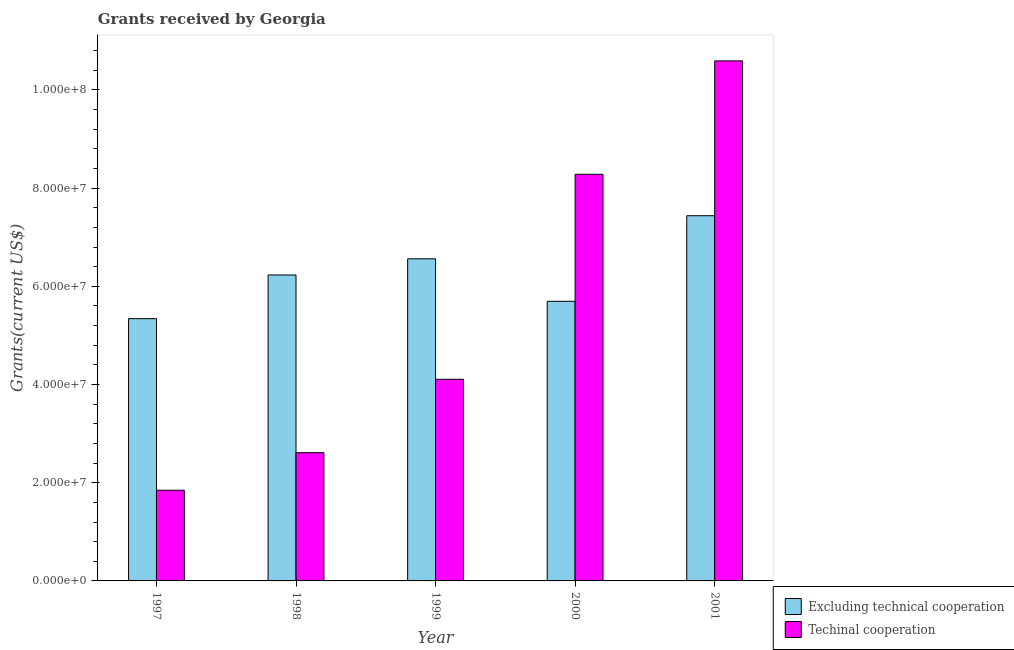How many different coloured bars are there?
Your answer should be very brief. 2. How many groups of bars are there?
Ensure brevity in your answer.  5. How many bars are there on the 3rd tick from the left?
Provide a succinct answer. 2. How many bars are there on the 5th tick from the right?
Keep it short and to the point. 2. In how many cases, is the number of bars for a given year not equal to the number of legend labels?
Offer a terse response. 0. What is the amount of grants received(excluding technical cooperation) in 1998?
Give a very brief answer. 6.23e+07. Across all years, what is the maximum amount of grants received(including technical cooperation)?
Ensure brevity in your answer.  1.06e+08. Across all years, what is the minimum amount of grants received(excluding technical cooperation)?
Your answer should be very brief. 5.34e+07. What is the total amount of grants received(excluding technical cooperation) in the graph?
Ensure brevity in your answer.  3.13e+08. What is the difference between the amount of grants received(including technical cooperation) in 1997 and that in 2000?
Keep it short and to the point. -6.44e+07. What is the difference between the amount of grants received(excluding technical cooperation) in 1997 and the amount of grants received(including technical cooperation) in 1998?
Give a very brief answer. -8.89e+06. What is the average amount of grants received(excluding technical cooperation) per year?
Offer a terse response. 6.25e+07. In how many years, is the amount of grants received(excluding technical cooperation) greater than 52000000 US$?
Provide a short and direct response. 5. What is the ratio of the amount of grants received(including technical cooperation) in 1998 to that in 2000?
Keep it short and to the point. 0.32. Is the amount of grants received(including technical cooperation) in 1997 less than that in 2001?
Keep it short and to the point. Yes. What is the difference between the highest and the second highest amount of grants received(excluding technical cooperation)?
Give a very brief answer. 8.77e+06. What is the difference between the highest and the lowest amount of grants received(including technical cooperation)?
Your answer should be very brief. 8.74e+07. Is the sum of the amount of grants received(including technical cooperation) in 1999 and 2000 greater than the maximum amount of grants received(excluding technical cooperation) across all years?
Offer a terse response. Yes. What does the 1st bar from the left in 2000 represents?
Offer a very short reply. Excluding technical cooperation. What does the 2nd bar from the right in 1998 represents?
Your answer should be very brief. Excluding technical cooperation. How many bars are there?
Offer a very short reply. 10. Are all the bars in the graph horizontal?
Your response must be concise. No. How many years are there in the graph?
Your answer should be compact. 5. Are the values on the major ticks of Y-axis written in scientific E-notation?
Make the answer very short. Yes. What is the title of the graph?
Your answer should be compact. Grants received by Georgia. What is the label or title of the Y-axis?
Your response must be concise. Grants(current US$). What is the Grants(current US$) of Excluding technical cooperation in 1997?
Provide a short and direct response. 5.34e+07. What is the Grants(current US$) of Techinal cooperation in 1997?
Provide a short and direct response. 1.85e+07. What is the Grants(current US$) of Excluding technical cooperation in 1998?
Make the answer very short. 6.23e+07. What is the Grants(current US$) in Techinal cooperation in 1998?
Your answer should be very brief. 2.61e+07. What is the Grants(current US$) in Excluding technical cooperation in 1999?
Provide a short and direct response. 6.56e+07. What is the Grants(current US$) in Techinal cooperation in 1999?
Offer a terse response. 4.11e+07. What is the Grants(current US$) in Excluding technical cooperation in 2000?
Offer a terse response. 5.70e+07. What is the Grants(current US$) of Techinal cooperation in 2000?
Your answer should be compact. 8.28e+07. What is the Grants(current US$) in Excluding technical cooperation in 2001?
Ensure brevity in your answer.  7.44e+07. What is the Grants(current US$) of Techinal cooperation in 2001?
Your response must be concise. 1.06e+08. Across all years, what is the maximum Grants(current US$) of Excluding technical cooperation?
Your response must be concise. 7.44e+07. Across all years, what is the maximum Grants(current US$) in Techinal cooperation?
Give a very brief answer. 1.06e+08. Across all years, what is the minimum Grants(current US$) of Excluding technical cooperation?
Offer a very short reply. 5.34e+07. Across all years, what is the minimum Grants(current US$) in Techinal cooperation?
Offer a very short reply. 1.85e+07. What is the total Grants(current US$) in Excluding technical cooperation in the graph?
Ensure brevity in your answer.  3.13e+08. What is the total Grants(current US$) of Techinal cooperation in the graph?
Your response must be concise. 2.74e+08. What is the difference between the Grants(current US$) of Excluding technical cooperation in 1997 and that in 1998?
Offer a very short reply. -8.89e+06. What is the difference between the Grants(current US$) in Techinal cooperation in 1997 and that in 1998?
Offer a very short reply. -7.65e+06. What is the difference between the Grants(current US$) in Excluding technical cooperation in 1997 and that in 1999?
Keep it short and to the point. -1.22e+07. What is the difference between the Grants(current US$) of Techinal cooperation in 1997 and that in 1999?
Ensure brevity in your answer.  -2.26e+07. What is the difference between the Grants(current US$) in Excluding technical cooperation in 1997 and that in 2000?
Give a very brief answer. -3.53e+06. What is the difference between the Grants(current US$) of Techinal cooperation in 1997 and that in 2000?
Make the answer very short. -6.44e+07. What is the difference between the Grants(current US$) of Excluding technical cooperation in 1997 and that in 2001?
Provide a short and direct response. -2.10e+07. What is the difference between the Grants(current US$) in Techinal cooperation in 1997 and that in 2001?
Give a very brief answer. -8.74e+07. What is the difference between the Grants(current US$) in Excluding technical cooperation in 1998 and that in 1999?
Give a very brief answer. -3.30e+06. What is the difference between the Grants(current US$) in Techinal cooperation in 1998 and that in 1999?
Offer a very short reply. -1.50e+07. What is the difference between the Grants(current US$) of Excluding technical cooperation in 1998 and that in 2000?
Ensure brevity in your answer.  5.36e+06. What is the difference between the Grants(current US$) of Techinal cooperation in 1998 and that in 2000?
Ensure brevity in your answer.  -5.67e+07. What is the difference between the Grants(current US$) of Excluding technical cooperation in 1998 and that in 2001?
Provide a succinct answer. -1.21e+07. What is the difference between the Grants(current US$) in Techinal cooperation in 1998 and that in 2001?
Give a very brief answer. -7.98e+07. What is the difference between the Grants(current US$) in Excluding technical cooperation in 1999 and that in 2000?
Your response must be concise. 8.66e+06. What is the difference between the Grants(current US$) of Techinal cooperation in 1999 and that in 2000?
Provide a short and direct response. -4.18e+07. What is the difference between the Grants(current US$) of Excluding technical cooperation in 1999 and that in 2001?
Your response must be concise. -8.77e+06. What is the difference between the Grants(current US$) of Techinal cooperation in 1999 and that in 2001?
Your answer should be compact. -6.48e+07. What is the difference between the Grants(current US$) of Excluding technical cooperation in 2000 and that in 2001?
Provide a short and direct response. -1.74e+07. What is the difference between the Grants(current US$) of Techinal cooperation in 2000 and that in 2001?
Provide a short and direct response. -2.31e+07. What is the difference between the Grants(current US$) of Excluding technical cooperation in 1997 and the Grants(current US$) of Techinal cooperation in 1998?
Make the answer very short. 2.73e+07. What is the difference between the Grants(current US$) of Excluding technical cooperation in 1997 and the Grants(current US$) of Techinal cooperation in 1999?
Provide a short and direct response. 1.24e+07. What is the difference between the Grants(current US$) of Excluding technical cooperation in 1997 and the Grants(current US$) of Techinal cooperation in 2000?
Your response must be concise. -2.94e+07. What is the difference between the Grants(current US$) in Excluding technical cooperation in 1997 and the Grants(current US$) in Techinal cooperation in 2001?
Your answer should be very brief. -5.25e+07. What is the difference between the Grants(current US$) in Excluding technical cooperation in 1998 and the Grants(current US$) in Techinal cooperation in 1999?
Make the answer very short. 2.12e+07. What is the difference between the Grants(current US$) in Excluding technical cooperation in 1998 and the Grants(current US$) in Techinal cooperation in 2000?
Provide a short and direct response. -2.05e+07. What is the difference between the Grants(current US$) in Excluding technical cooperation in 1998 and the Grants(current US$) in Techinal cooperation in 2001?
Provide a succinct answer. -4.36e+07. What is the difference between the Grants(current US$) in Excluding technical cooperation in 1999 and the Grants(current US$) in Techinal cooperation in 2000?
Provide a short and direct response. -1.72e+07. What is the difference between the Grants(current US$) of Excluding technical cooperation in 1999 and the Grants(current US$) of Techinal cooperation in 2001?
Your response must be concise. -4.03e+07. What is the difference between the Grants(current US$) in Excluding technical cooperation in 2000 and the Grants(current US$) in Techinal cooperation in 2001?
Your answer should be compact. -4.90e+07. What is the average Grants(current US$) of Excluding technical cooperation per year?
Provide a short and direct response. 6.25e+07. What is the average Grants(current US$) in Techinal cooperation per year?
Make the answer very short. 5.49e+07. In the year 1997, what is the difference between the Grants(current US$) of Excluding technical cooperation and Grants(current US$) of Techinal cooperation?
Make the answer very short. 3.50e+07. In the year 1998, what is the difference between the Grants(current US$) in Excluding technical cooperation and Grants(current US$) in Techinal cooperation?
Give a very brief answer. 3.62e+07. In the year 1999, what is the difference between the Grants(current US$) in Excluding technical cooperation and Grants(current US$) in Techinal cooperation?
Make the answer very short. 2.45e+07. In the year 2000, what is the difference between the Grants(current US$) of Excluding technical cooperation and Grants(current US$) of Techinal cooperation?
Provide a short and direct response. -2.59e+07. In the year 2001, what is the difference between the Grants(current US$) in Excluding technical cooperation and Grants(current US$) in Techinal cooperation?
Offer a very short reply. -3.15e+07. What is the ratio of the Grants(current US$) of Excluding technical cooperation in 1997 to that in 1998?
Offer a very short reply. 0.86. What is the ratio of the Grants(current US$) of Techinal cooperation in 1997 to that in 1998?
Provide a short and direct response. 0.71. What is the ratio of the Grants(current US$) in Excluding technical cooperation in 1997 to that in 1999?
Keep it short and to the point. 0.81. What is the ratio of the Grants(current US$) of Techinal cooperation in 1997 to that in 1999?
Ensure brevity in your answer.  0.45. What is the ratio of the Grants(current US$) of Excluding technical cooperation in 1997 to that in 2000?
Give a very brief answer. 0.94. What is the ratio of the Grants(current US$) in Techinal cooperation in 1997 to that in 2000?
Your response must be concise. 0.22. What is the ratio of the Grants(current US$) of Excluding technical cooperation in 1997 to that in 2001?
Offer a terse response. 0.72. What is the ratio of the Grants(current US$) of Techinal cooperation in 1997 to that in 2001?
Your answer should be compact. 0.17. What is the ratio of the Grants(current US$) in Excluding technical cooperation in 1998 to that in 1999?
Provide a succinct answer. 0.95. What is the ratio of the Grants(current US$) of Techinal cooperation in 1998 to that in 1999?
Offer a terse response. 0.64. What is the ratio of the Grants(current US$) of Excluding technical cooperation in 1998 to that in 2000?
Ensure brevity in your answer.  1.09. What is the ratio of the Grants(current US$) in Techinal cooperation in 1998 to that in 2000?
Keep it short and to the point. 0.32. What is the ratio of the Grants(current US$) of Excluding technical cooperation in 1998 to that in 2001?
Keep it short and to the point. 0.84. What is the ratio of the Grants(current US$) in Techinal cooperation in 1998 to that in 2001?
Give a very brief answer. 0.25. What is the ratio of the Grants(current US$) of Excluding technical cooperation in 1999 to that in 2000?
Your response must be concise. 1.15. What is the ratio of the Grants(current US$) of Techinal cooperation in 1999 to that in 2000?
Provide a short and direct response. 0.5. What is the ratio of the Grants(current US$) in Excluding technical cooperation in 1999 to that in 2001?
Your response must be concise. 0.88. What is the ratio of the Grants(current US$) of Techinal cooperation in 1999 to that in 2001?
Provide a short and direct response. 0.39. What is the ratio of the Grants(current US$) of Excluding technical cooperation in 2000 to that in 2001?
Ensure brevity in your answer.  0.77. What is the ratio of the Grants(current US$) of Techinal cooperation in 2000 to that in 2001?
Your answer should be very brief. 0.78. What is the difference between the highest and the second highest Grants(current US$) in Excluding technical cooperation?
Provide a succinct answer. 8.77e+06. What is the difference between the highest and the second highest Grants(current US$) in Techinal cooperation?
Your answer should be compact. 2.31e+07. What is the difference between the highest and the lowest Grants(current US$) of Excluding technical cooperation?
Offer a very short reply. 2.10e+07. What is the difference between the highest and the lowest Grants(current US$) of Techinal cooperation?
Provide a succinct answer. 8.74e+07. 